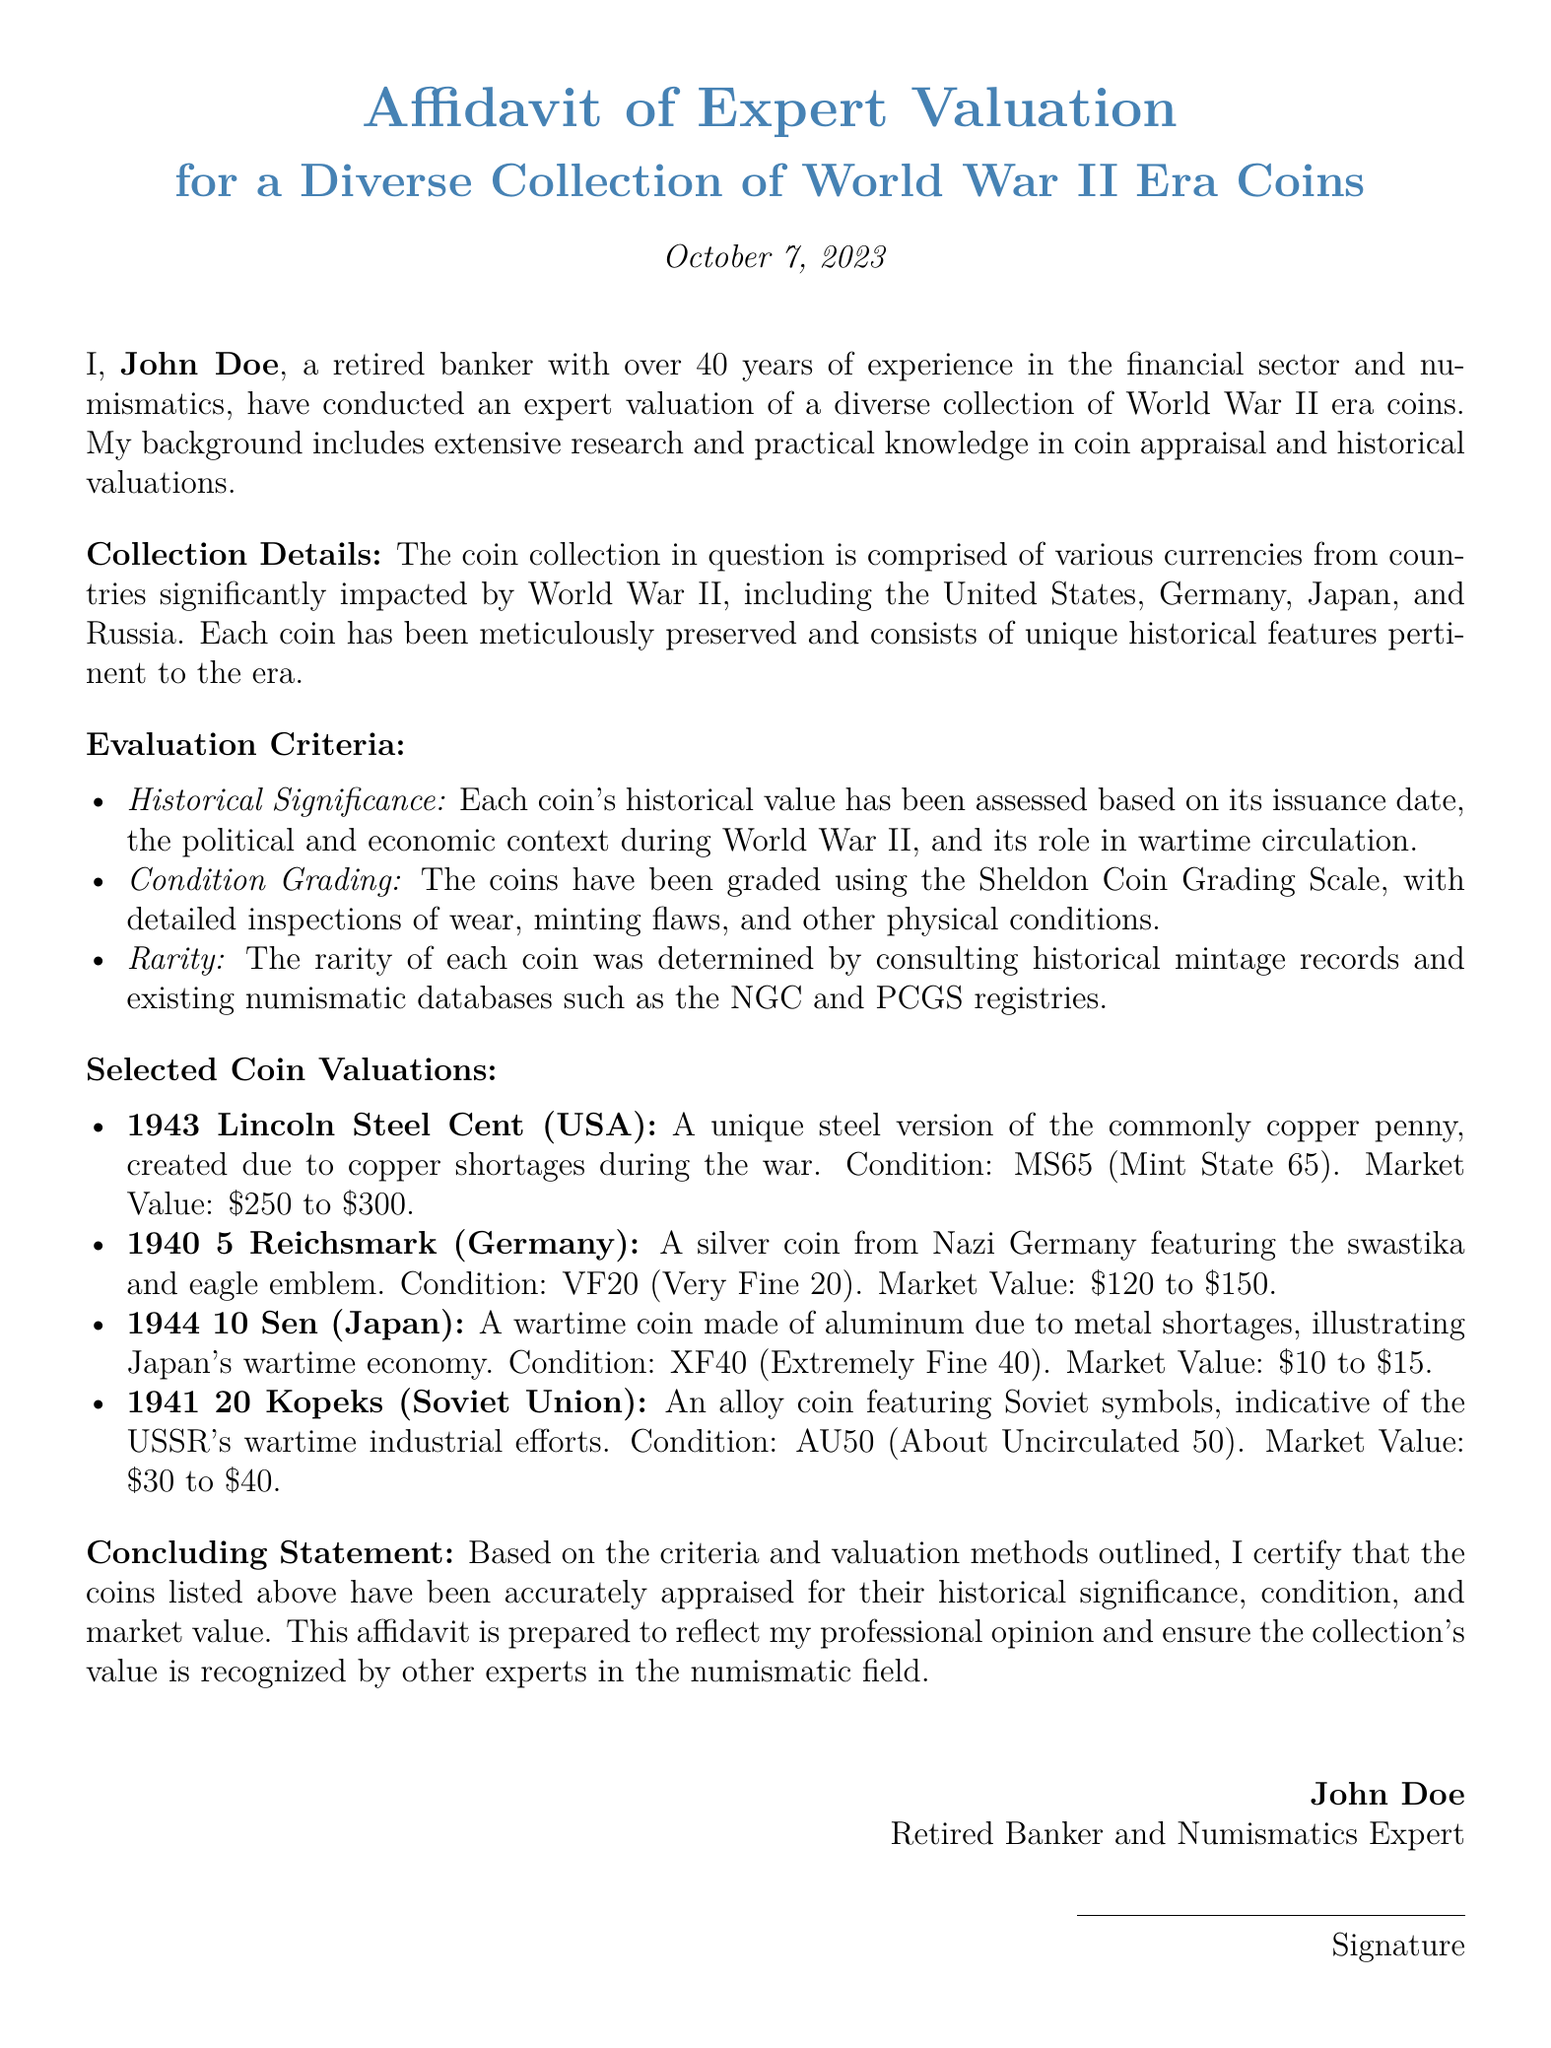What is the name of the expert valuing the coin collection? The affidavit states that the expert valuing the collection is John Doe.
Answer: John Doe What date was the affidavit signed? The document mentions that the affidavit was prepared on October 7, 2023.
Answer: October 7, 2023 Which grading scale was used for the coins? The evaluation mentions the Sheldon Coin Grading Scale for assessing coin conditions.
Answer: Sheldon Coin Grading Scale What is the market value range for the 1943 Lincoln Steel Cent? The document specifies that the market value for this coin ranges from $250 to $300.
Answer: $250 to $300 How many countries' coins are mentioned in the collection? The affidavit indicates that coins from four countries are included: the United States, Germany, Japan, and Russia.
Answer: Four What is the condition grade for the 1940 5 Reichsmark? The condition for the 1940 5 Reichsmark coin is graded as Very Fine 20.
Answer: VF20 What type of currency is the 1944 10 Sen made from? The affidavit describes the 1944 10 Sen as being made of aluminum due to metal shortages during the war.
Answer: Aluminum What is the historical significance criterion based on? The historical significance is assessed based on issuance date, political context, and wartime circulation.
Answer: Issuance date, political context, and wartime circulation 